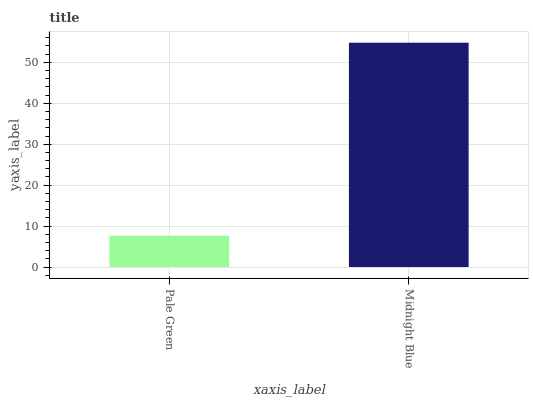Is Pale Green the minimum?
Answer yes or no. Yes. Is Midnight Blue the maximum?
Answer yes or no. Yes. Is Midnight Blue the minimum?
Answer yes or no. No. Is Midnight Blue greater than Pale Green?
Answer yes or no. Yes. Is Pale Green less than Midnight Blue?
Answer yes or no. Yes. Is Pale Green greater than Midnight Blue?
Answer yes or no. No. Is Midnight Blue less than Pale Green?
Answer yes or no. No. Is Midnight Blue the high median?
Answer yes or no. Yes. Is Pale Green the low median?
Answer yes or no. Yes. Is Pale Green the high median?
Answer yes or no. No. Is Midnight Blue the low median?
Answer yes or no. No. 